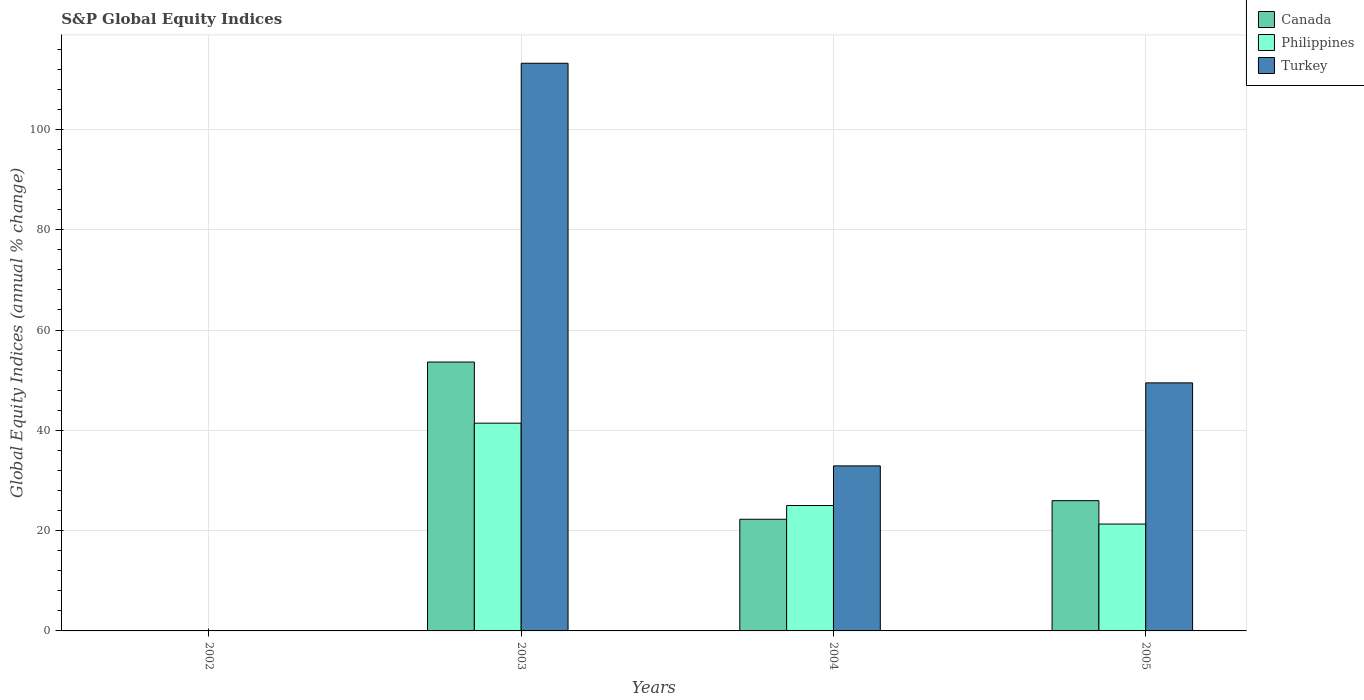How many different coloured bars are there?
Make the answer very short. 3. Are the number of bars per tick equal to the number of legend labels?
Ensure brevity in your answer.  No. Are the number of bars on each tick of the X-axis equal?
Your answer should be very brief. No. What is the label of the 1st group of bars from the left?
Your response must be concise. 2002. In how many cases, is the number of bars for a given year not equal to the number of legend labels?
Your answer should be very brief. 1. What is the global equity indices in Turkey in 2004?
Your response must be concise. 32.91. Across all years, what is the maximum global equity indices in Turkey?
Offer a very short reply. 113.2. Across all years, what is the minimum global equity indices in Turkey?
Ensure brevity in your answer.  0. What is the total global equity indices in Canada in the graph?
Give a very brief answer. 101.87. What is the difference between the global equity indices in Canada in 2003 and that in 2004?
Your answer should be compact. 31.35. What is the difference between the global equity indices in Philippines in 2005 and the global equity indices in Canada in 2002?
Ensure brevity in your answer.  21.31. What is the average global equity indices in Turkey per year?
Provide a short and direct response. 48.89. In the year 2004, what is the difference between the global equity indices in Canada and global equity indices in Turkey?
Make the answer very short. -10.64. In how many years, is the global equity indices in Philippines greater than 76 %?
Your response must be concise. 0. What is the ratio of the global equity indices in Canada in 2004 to that in 2005?
Your answer should be very brief. 0.86. Is the difference between the global equity indices in Canada in 2003 and 2005 greater than the difference between the global equity indices in Turkey in 2003 and 2005?
Your answer should be compact. No. What is the difference between the highest and the second highest global equity indices in Canada?
Offer a terse response. 27.65. What is the difference between the highest and the lowest global equity indices in Turkey?
Make the answer very short. 113.2. Are all the bars in the graph horizontal?
Your response must be concise. No. Where does the legend appear in the graph?
Offer a terse response. Top right. What is the title of the graph?
Offer a very short reply. S&P Global Equity Indices. What is the label or title of the Y-axis?
Ensure brevity in your answer.  Global Equity Indices (annual % change). What is the Global Equity Indices (annual % change) in Canada in 2002?
Your response must be concise. 0. What is the Global Equity Indices (annual % change) of Turkey in 2002?
Keep it short and to the point. 0. What is the Global Equity Indices (annual % change) in Canada in 2003?
Give a very brief answer. 53.62. What is the Global Equity Indices (annual % change) of Philippines in 2003?
Your response must be concise. 41.43. What is the Global Equity Indices (annual % change) in Turkey in 2003?
Give a very brief answer. 113.2. What is the Global Equity Indices (annual % change) in Canada in 2004?
Your response must be concise. 22.27. What is the Global Equity Indices (annual % change) in Philippines in 2004?
Your response must be concise. 25.01. What is the Global Equity Indices (annual % change) of Turkey in 2004?
Your answer should be very brief. 32.91. What is the Global Equity Indices (annual % change) of Canada in 2005?
Your response must be concise. 25.98. What is the Global Equity Indices (annual % change) of Philippines in 2005?
Make the answer very short. 21.31. What is the Global Equity Indices (annual % change) of Turkey in 2005?
Make the answer very short. 49.47. Across all years, what is the maximum Global Equity Indices (annual % change) in Canada?
Ensure brevity in your answer.  53.62. Across all years, what is the maximum Global Equity Indices (annual % change) in Philippines?
Give a very brief answer. 41.43. Across all years, what is the maximum Global Equity Indices (annual % change) in Turkey?
Ensure brevity in your answer.  113.2. What is the total Global Equity Indices (annual % change) in Canada in the graph?
Offer a terse response. 101.87. What is the total Global Equity Indices (annual % change) in Philippines in the graph?
Make the answer very short. 87.75. What is the total Global Equity Indices (annual % change) in Turkey in the graph?
Offer a terse response. 195.58. What is the difference between the Global Equity Indices (annual % change) of Canada in 2003 and that in 2004?
Keep it short and to the point. 31.35. What is the difference between the Global Equity Indices (annual % change) of Philippines in 2003 and that in 2004?
Your response must be concise. 16.42. What is the difference between the Global Equity Indices (annual % change) in Turkey in 2003 and that in 2004?
Provide a succinct answer. 80.29. What is the difference between the Global Equity Indices (annual % change) in Canada in 2003 and that in 2005?
Your answer should be very brief. 27.65. What is the difference between the Global Equity Indices (annual % change) in Philippines in 2003 and that in 2005?
Give a very brief answer. 20.12. What is the difference between the Global Equity Indices (annual % change) in Turkey in 2003 and that in 2005?
Offer a terse response. 63.73. What is the difference between the Global Equity Indices (annual % change) in Canada in 2004 and that in 2005?
Ensure brevity in your answer.  -3.71. What is the difference between the Global Equity Indices (annual % change) in Philippines in 2004 and that in 2005?
Give a very brief answer. 3.7. What is the difference between the Global Equity Indices (annual % change) in Turkey in 2004 and that in 2005?
Offer a terse response. -16.56. What is the difference between the Global Equity Indices (annual % change) in Canada in 2003 and the Global Equity Indices (annual % change) in Philippines in 2004?
Offer a terse response. 28.61. What is the difference between the Global Equity Indices (annual % change) in Canada in 2003 and the Global Equity Indices (annual % change) in Turkey in 2004?
Your response must be concise. 20.71. What is the difference between the Global Equity Indices (annual % change) of Philippines in 2003 and the Global Equity Indices (annual % change) of Turkey in 2004?
Keep it short and to the point. 8.52. What is the difference between the Global Equity Indices (annual % change) in Canada in 2003 and the Global Equity Indices (annual % change) in Philippines in 2005?
Ensure brevity in your answer.  32.31. What is the difference between the Global Equity Indices (annual % change) of Canada in 2003 and the Global Equity Indices (annual % change) of Turkey in 2005?
Ensure brevity in your answer.  4.16. What is the difference between the Global Equity Indices (annual % change) of Philippines in 2003 and the Global Equity Indices (annual % change) of Turkey in 2005?
Your response must be concise. -8.04. What is the difference between the Global Equity Indices (annual % change) in Canada in 2004 and the Global Equity Indices (annual % change) in Philippines in 2005?
Offer a terse response. 0.96. What is the difference between the Global Equity Indices (annual % change) in Canada in 2004 and the Global Equity Indices (annual % change) in Turkey in 2005?
Ensure brevity in your answer.  -27.2. What is the difference between the Global Equity Indices (annual % change) of Philippines in 2004 and the Global Equity Indices (annual % change) of Turkey in 2005?
Your answer should be compact. -24.46. What is the average Global Equity Indices (annual % change) in Canada per year?
Keep it short and to the point. 25.47. What is the average Global Equity Indices (annual % change) of Philippines per year?
Your answer should be very brief. 21.94. What is the average Global Equity Indices (annual % change) in Turkey per year?
Your answer should be very brief. 48.89. In the year 2003, what is the difference between the Global Equity Indices (annual % change) in Canada and Global Equity Indices (annual % change) in Philippines?
Your response must be concise. 12.19. In the year 2003, what is the difference between the Global Equity Indices (annual % change) in Canada and Global Equity Indices (annual % change) in Turkey?
Your response must be concise. -59.58. In the year 2003, what is the difference between the Global Equity Indices (annual % change) in Philippines and Global Equity Indices (annual % change) in Turkey?
Offer a very short reply. -71.77. In the year 2004, what is the difference between the Global Equity Indices (annual % change) of Canada and Global Equity Indices (annual % change) of Philippines?
Your response must be concise. -2.74. In the year 2004, what is the difference between the Global Equity Indices (annual % change) of Canada and Global Equity Indices (annual % change) of Turkey?
Ensure brevity in your answer.  -10.64. In the year 2004, what is the difference between the Global Equity Indices (annual % change) of Philippines and Global Equity Indices (annual % change) of Turkey?
Your answer should be very brief. -7.9. In the year 2005, what is the difference between the Global Equity Indices (annual % change) of Canada and Global Equity Indices (annual % change) of Philippines?
Offer a terse response. 4.66. In the year 2005, what is the difference between the Global Equity Indices (annual % change) of Canada and Global Equity Indices (annual % change) of Turkey?
Make the answer very short. -23.49. In the year 2005, what is the difference between the Global Equity Indices (annual % change) of Philippines and Global Equity Indices (annual % change) of Turkey?
Keep it short and to the point. -28.15. What is the ratio of the Global Equity Indices (annual % change) of Canada in 2003 to that in 2004?
Offer a terse response. 2.41. What is the ratio of the Global Equity Indices (annual % change) of Philippines in 2003 to that in 2004?
Give a very brief answer. 1.66. What is the ratio of the Global Equity Indices (annual % change) in Turkey in 2003 to that in 2004?
Keep it short and to the point. 3.44. What is the ratio of the Global Equity Indices (annual % change) of Canada in 2003 to that in 2005?
Provide a succinct answer. 2.06. What is the ratio of the Global Equity Indices (annual % change) of Philippines in 2003 to that in 2005?
Your response must be concise. 1.94. What is the ratio of the Global Equity Indices (annual % change) of Turkey in 2003 to that in 2005?
Keep it short and to the point. 2.29. What is the ratio of the Global Equity Indices (annual % change) of Canada in 2004 to that in 2005?
Give a very brief answer. 0.86. What is the ratio of the Global Equity Indices (annual % change) in Philippines in 2004 to that in 2005?
Make the answer very short. 1.17. What is the ratio of the Global Equity Indices (annual % change) in Turkey in 2004 to that in 2005?
Your answer should be very brief. 0.67. What is the difference between the highest and the second highest Global Equity Indices (annual % change) of Canada?
Give a very brief answer. 27.65. What is the difference between the highest and the second highest Global Equity Indices (annual % change) of Philippines?
Offer a very short reply. 16.42. What is the difference between the highest and the second highest Global Equity Indices (annual % change) of Turkey?
Keep it short and to the point. 63.73. What is the difference between the highest and the lowest Global Equity Indices (annual % change) of Canada?
Offer a very short reply. 53.62. What is the difference between the highest and the lowest Global Equity Indices (annual % change) of Philippines?
Your response must be concise. 41.43. What is the difference between the highest and the lowest Global Equity Indices (annual % change) in Turkey?
Keep it short and to the point. 113.2. 